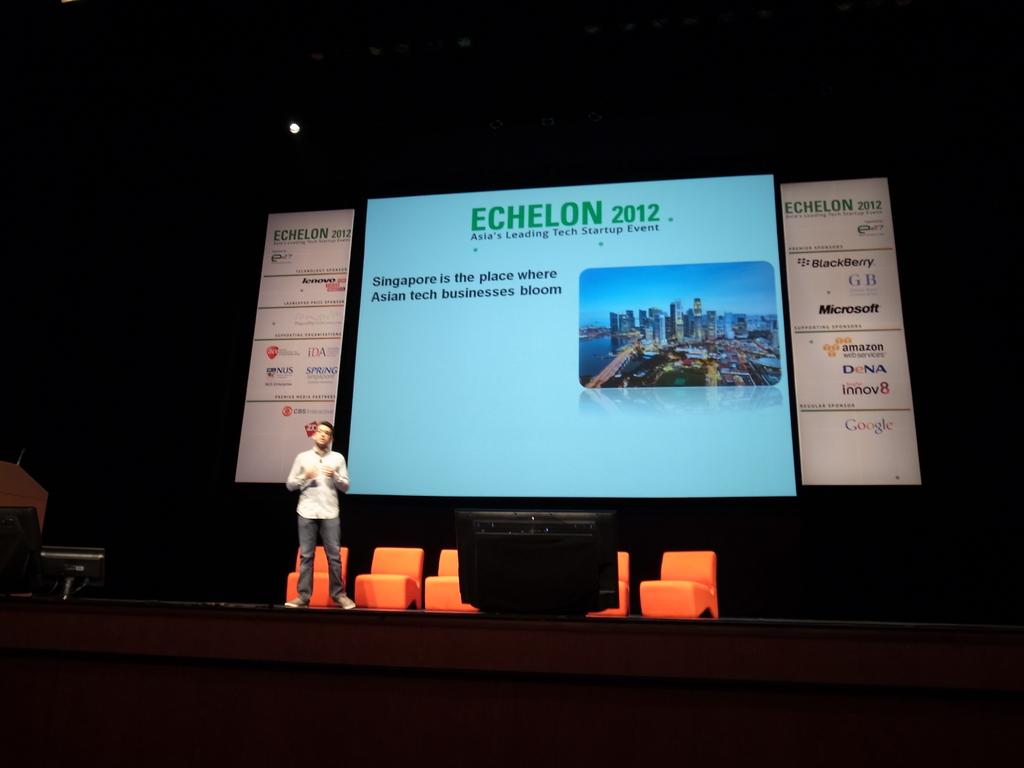What kind of center is this?
Give a very brief answer. Unanswerable. What year is presented on the powerpoint?
Provide a short and direct response. 2012. 